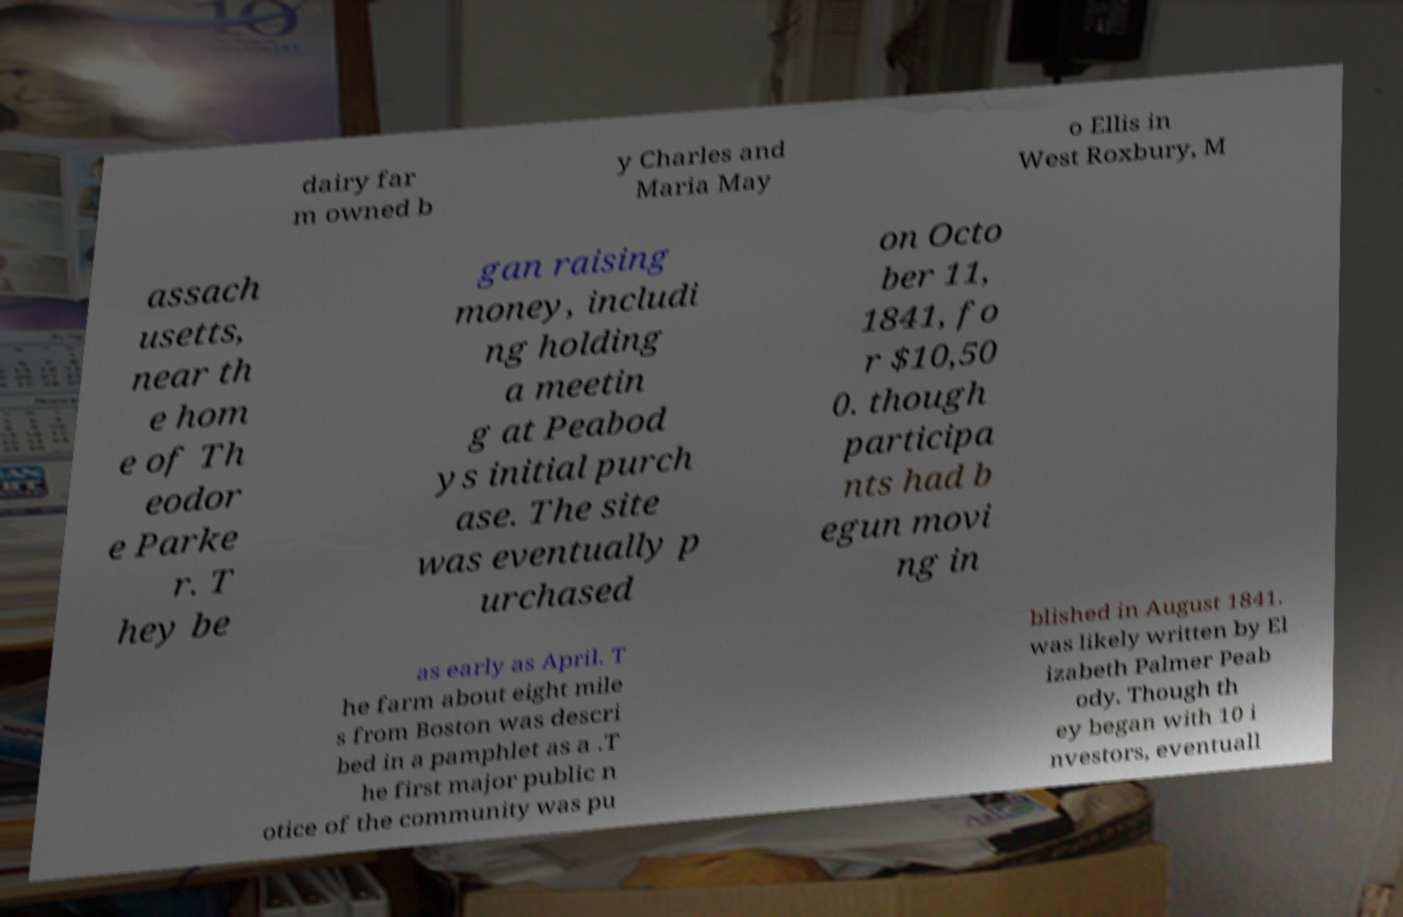There's text embedded in this image that I need extracted. Can you transcribe it verbatim? dairy far m owned b y Charles and Maria May o Ellis in West Roxbury, M assach usetts, near th e hom e of Th eodor e Parke r. T hey be gan raising money, includi ng holding a meetin g at Peabod ys initial purch ase. The site was eventually p urchased on Octo ber 11, 1841, fo r $10,50 0. though participa nts had b egun movi ng in as early as April. T he farm about eight mile s from Boston was descri bed in a pamphlet as a .T he first major public n otice of the community was pu blished in August 1841. was likely written by El izabeth Palmer Peab ody. Though th ey began with 10 i nvestors, eventuall 